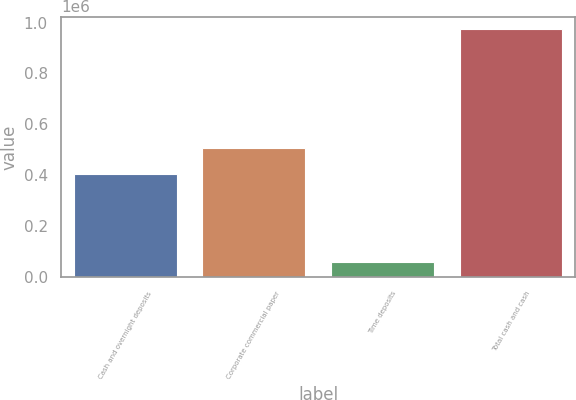Convert chart. <chart><loc_0><loc_0><loc_500><loc_500><bar_chart><fcel>Cash and overnight deposits<fcel>Corporate commercial paper<fcel>Time deposits<fcel>Total cash and cash<nl><fcel>406787<fcel>507889<fcel>59871<fcel>974547<nl></chart> 